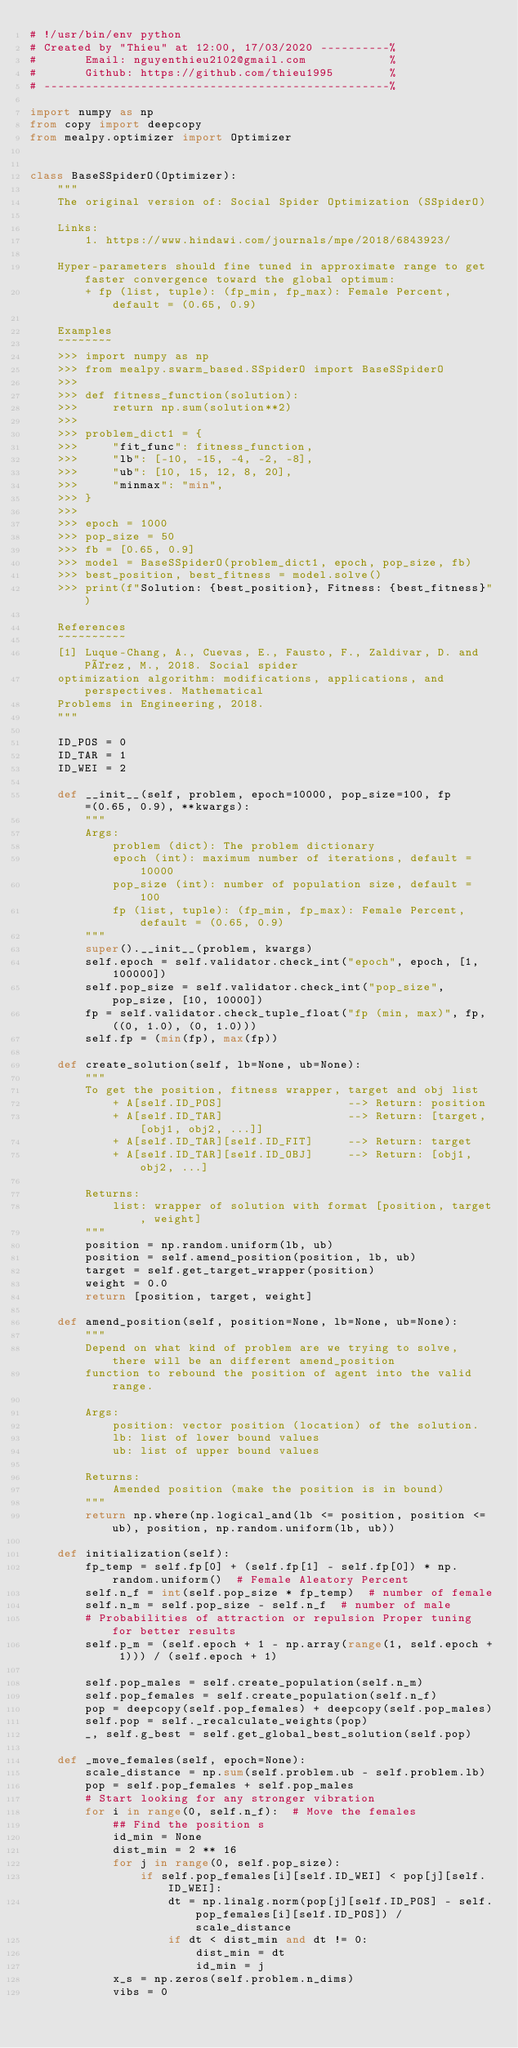Convert code to text. <code><loc_0><loc_0><loc_500><loc_500><_Python_># !/usr/bin/env python
# Created by "Thieu" at 12:00, 17/03/2020 ----------%
#       Email: nguyenthieu2102@gmail.com            %
#       Github: https://github.com/thieu1995        %
# --------------------------------------------------%

import numpy as np
from copy import deepcopy
from mealpy.optimizer import Optimizer


class BaseSSpiderO(Optimizer):
    """
    The original version of: Social Spider Optimization (SSpiderO)

    Links:
        1. https://www.hindawi.com/journals/mpe/2018/6843923/

    Hyper-parameters should fine tuned in approximate range to get faster convergence toward the global optimum:
        + fp (list, tuple): (fp_min, fp_max): Female Percent, default = (0.65, 0.9)

    Examples
    ~~~~~~~~
    >>> import numpy as np
    >>> from mealpy.swarm_based.SSpiderO import BaseSSpiderO
    >>>
    >>> def fitness_function(solution):
    >>>     return np.sum(solution**2)
    >>>
    >>> problem_dict1 = {
    >>>     "fit_func": fitness_function,
    >>>     "lb": [-10, -15, -4, -2, -8],
    >>>     "ub": [10, 15, 12, 8, 20],
    >>>     "minmax": "min",
    >>> }
    >>>
    >>> epoch = 1000
    >>> pop_size = 50
    >>> fb = [0.65, 0.9]
    >>> model = BaseSSpiderO(problem_dict1, epoch, pop_size, fb)
    >>> best_position, best_fitness = model.solve()
    >>> print(f"Solution: {best_position}, Fitness: {best_fitness}")

    References
    ~~~~~~~~~~
    [1] Luque-Chang, A., Cuevas, E., Fausto, F., Zaldivar, D. and Pérez, M., 2018. Social spider
    optimization algorithm: modifications, applications, and perspectives. Mathematical
    Problems in Engineering, 2018.
    """

    ID_POS = 0
    ID_TAR = 1
    ID_WEI = 2

    def __init__(self, problem, epoch=10000, pop_size=100, fp=(0.65, 0.9), **kwargs):
        """
        Args:
            problem (dict): The problem dictionary
            epoch (int): maximum number of iterations, default = 10000
            pop_size (int): number of population size, default = 100
            fp (list, tuple): (fp_min, fp_max): Female Percent, default = (0.65, 0.9)
        """
        super().__init__(problem, kwargs)
        self.epoch = self.validator.check_int("epoch", epoch, [1, 100000])
        self.pop_size = self.validator.check_int("pop_size", pop_size, [10, 10000])
        fp = self.validator.check_tuple_float("fp (min, max)", fp, ((0, 1.0), (0, 1.0)))
        self.fp = (min(fp), max(fp))

    def create_solution(self, lb=None, ub=None):
        """
        To get the position, fitness wrapper, target and obj list
            + A[self.ID_POS]                  --> Return: position
            + A[self.ID_TAR]                  --> Return: [target, [obj1, obj2, ...]]
            + A[self.ID_TAR][self.ID_FIT]     --> Return: target
            + A[self.ID_TAR][self.ID_OBJ]     --> Return: [obj1, obj2, ...]

        Returns:
            list: wrapper of solution with format [position, target, weight]
        """
        position = np.random.uniform(lb, ub)
        position = self.amend_position(position, lb, ub)
        target = self.get_target_wrapper(position)
        weight = 0.0
        return [position, target, weight]

    def amend_position(self, position=None, lb=None, ub=None):
        """
        Depend on what kind of problem are we trying to solve, there will be an different amend_position
        function to rebound the position of agent into the valid range.

        Args:
            position: vector position (location) of the solution.
            lb: list of lower bound values
            ub: list of upper bound values

        Returns:
            Amended position (make the position is in bound)
        """
        return np.where(np.logical_and(lb <= position, position <= ub), position, np.random.uniform(lb, ub))

    def initialization(self):
        fp_temp = self.fp[0] + (self.fp[1] - self.fp[0]) * np.random.uniform()  # Female Aleatory Percent
        self.n_f = int(self.pop_size * fp_temp)  # number of female
        self.n_m = self.pop_size - self.n_f  # number of male
        # Probabilities of attraction or repulsion Proper tuning for better results
        self.p_m = (self.epoch + 1 - np.array(range(1, self.epoch + 1))) / (self.epoch + 1)

        self.pop_males = self.create_population(self.n_m)
        self.pop_females = self.create_population(self.n_f)
        pop = deepcopy(self.pop_females) + deepcopy(self.pop_males)
        self.pop = self._recalculate_weights(pop)
        _, self.g_best = self.get_global_best_solution(self.pop)

    def _move_females(self, epoch=None):
        scale_distance = np.sum(self.problem.ub - self.problem.lb)
        pop = self.pop_females + self.pop_males
        # Start looking for any stronger vibration
        for i in range(0, self.n_f):  # Move the females
            ## Find the position s
            id_min = None
            dist_min = 2 ** 16
            for j in range(0, self.pop_size):
                if self.pop_females[i][self.ID_WEI] < pop[j][self.ID_WEI]:
                    dt = np.linalg.norm(pop[j][self.ID_POS] - self.pop_females[i][self.ID_POS]) / scale_distance
                    if dt < dist_min and dt != 0:
                        dist_min = dt
                        id_min = j
            x_s = np.zeros(self.problem.n_dims)
            vibs = 0</code> 